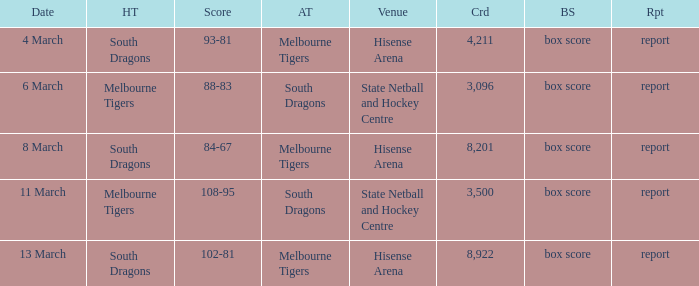Where was the venue with 3,096 in the crowd and against the Melbourne Tigers? Hisense Arena, Hisense Arena, Hisense Arena. 